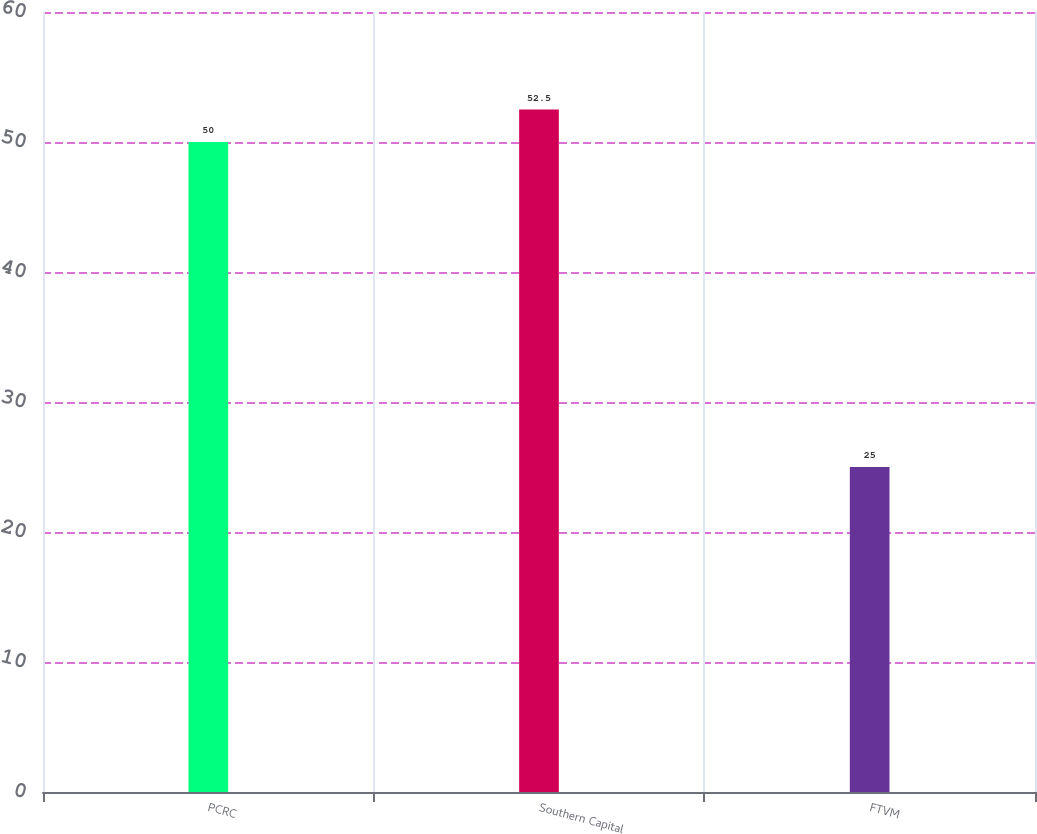Convert chart to OTSL. <chart><loc_0><loc_0><loc_500><loc_500><bar_chart><fcel>PCRC<fcel>Southern Capital<fcel>FTVM<nl><fcel>50<fcel>52.5<fcel>25<nl></chart> 